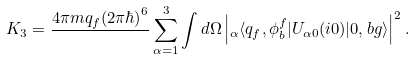<formula> <loc_0><loc_0><loc_500><loc_500>K _ { 3 } = \frac { 4 \pi m q _ { f } ( 2 \pi \hbar { ) } ^ { 6 } } { } \sum _ { \alpha = 1 } ^ { 3 } \int d \Omega \left | { _ { \alpha } } \langle q _ { f } , \phi _ { b } ^ { f } | U _ { \alpha 0 } ( i 0 ) | 0 , b g \rangle \right | ^ { 2 } .</formula> 